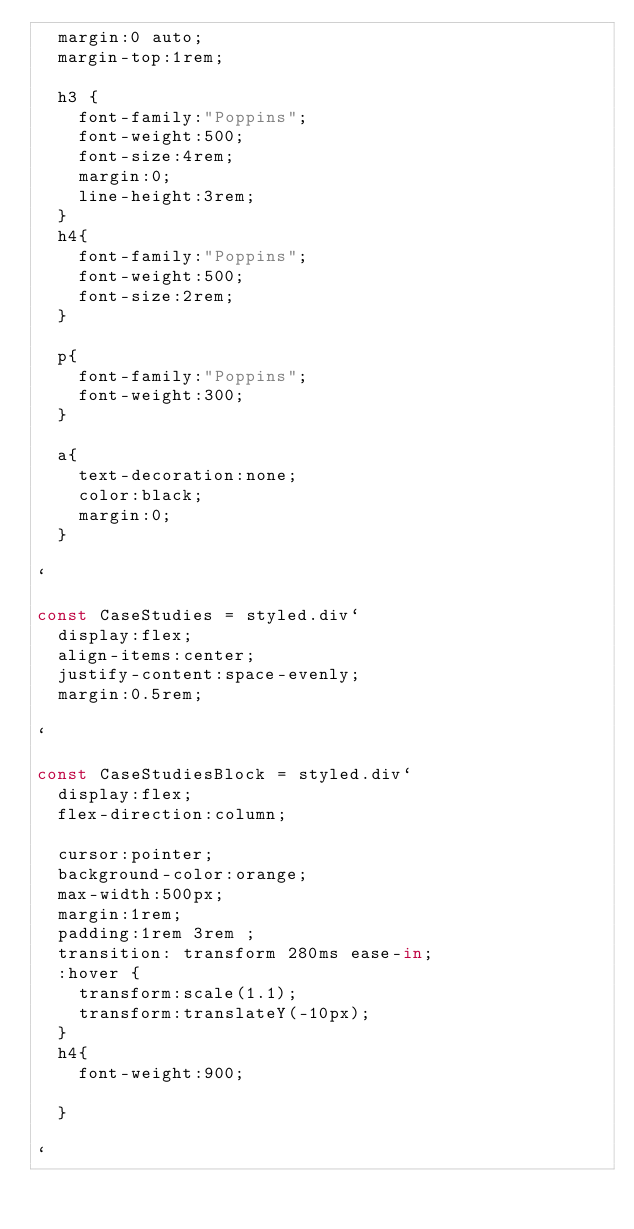<code> <loc_0><loc_0><loc_500><loc_500><_JavaScript_>  margin:0 auto;
  margin-top:1rem;
  
  h3 {
    font-family:"Poppins";
    font-weight:500;
    font-size:4rem;
    margin:0;
    line-height:3rem;
  }
  h4{
    font-family:"Poppins";
    font-weight:500;
    font-size:2rem;
  }

  p{
    font-family:"Poppins";
    font-weight:300;
  }

  a{
    text-decoration:none;
    color:black;
    margin:0;
  }

`

const CaseStudies = styled.div`
  display:flex;
  align-items:center;
  justify-content:space-evenly;
  margin:0.5rem;

`

const CaseStudiesBlock = styled.div`
  display:flex;
  flex-direction:column;

  cursor:pointer;
  background-color:orange;
  max-width:500px;
  margin:1rem;
  padding:1rem 3rem ;
  transition: transform 280ms ease-in;
  :hover {
    transform:scale(1.1);
    transform:translateY(-10px);
  }
  h4{
    font-weight:900;

  }

`
</code> 